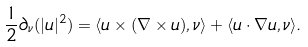Convert formula to latex. <formula><loc_0><loc_0><loc_500><loc_500>\frac { 1 } { 2 } \partial _ { \nu } ( | u | ^ { 2 } ) = \langle u \times ( \nabla \times u ) , \nu \rangle + \langle u \cdot \nabla u , \nu \rangle .</formula> 